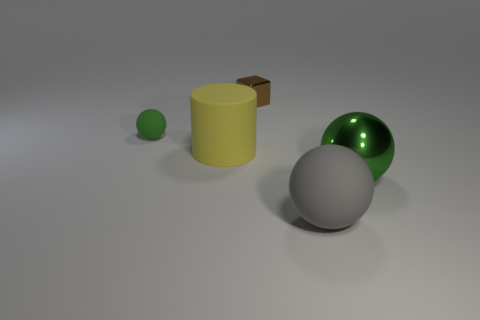Subtract all green spheres. How many were subtracted if there are1green spheres left? 1 Subtract 0 cyan cubes. How many objects are left? 5 Subtract all cylinders. How many objects are left? 4 Subtract 1 balls. How many balls are left? 2 Subtract all brown spheres. Subtract all blue cylinders. How many spheres are left? 3 Subtract all brown cylinders. How many cyan blocks are left? 0 Subtract all big green objects. Subtract all big green metallic objects. How many objects are left? 3 Add 4 tiny brown shiny blocks. How many tiny brown shiny blocks are left? 5 Add 4 large purple matte balls. How many large purple matte balls exist? 4 Add 1 yellow rubber things. How many objects exist? 6 